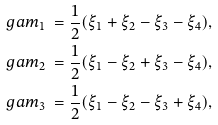Convert formula to latex. <formula><loc_0><loc_0><loc_500><loc_500>\ g a m _ { 1 } & \ = \frac { 1 } { 2 } ( \xi _ { 1 } + \xi _ { 2 } - \xi _ { 3 } - \xi _ { 4 } ) , \\ \ g a m _ { 2 } & \ = \frac { 1 } { 2 } ( \xi _ { 1 } - \xi _ { 2 } + \xi _ { 3 } - \xi _ { 4 } ) , \\ \ g a m _ { 3 } & \ = \frac { 1 } { 2 } ( \xi _ { 1 } - \xi _ { 2 } - \xi _ { 3 } + \xi _ { 4 } ) ,</formula> 